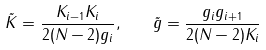<formula> <loc_0><loc_0><loc_500><loc_500>\tilde { K } = \frac { K _ { i - 1 } K _ { i } } { 2 ( N - 2 ) g _ { i } } , \quad \tilde { g } = \frac { g _ { i } g _ { i + 1 } } { 2 ( N - 2 ) K _ { i } }</formula> 